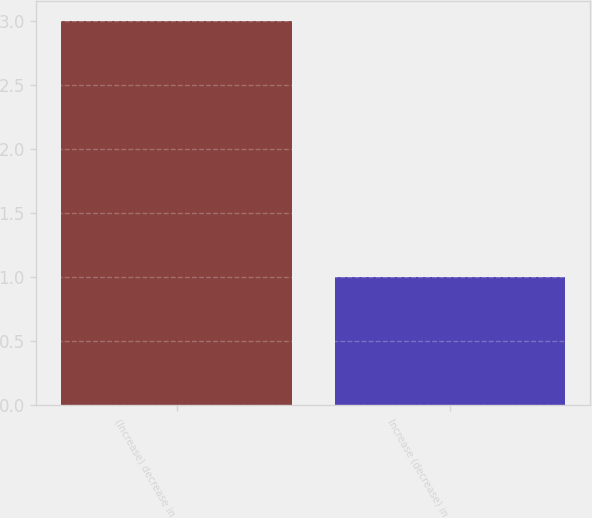Convert chart. <chart><loc_0><loc_0><loc_500><loc_500><bar_chart><fcel>(Increase) decrease in<fcel>Increase (decrease) in<nl><fcel>3<fcel>1<nl></chart> 